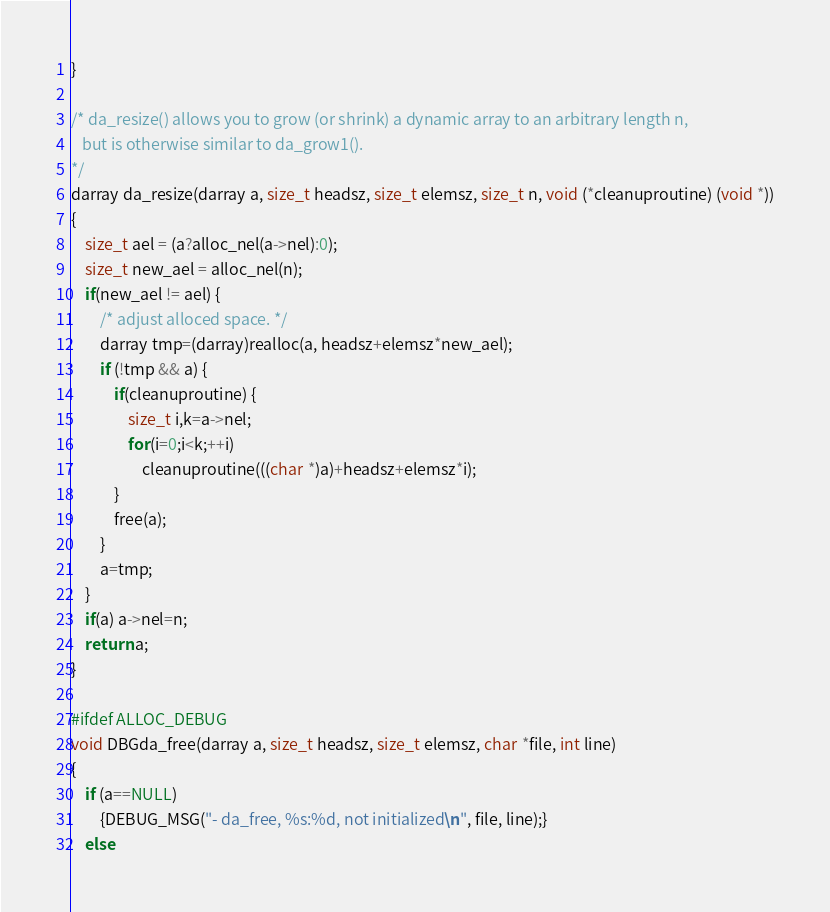Convert code to text. <code><loc_0><loc_0><loc_500><loc_500><_C_>}

/* da_resize() allows you to grow (or shrink) a dynamic array to an arbitrary length n,
   but is otherwise similar to da_grow1().
*/
darray da_resize(darray a, size_t headsz, size_t elemsz, size_t n, void (*cleanuproutine) (void *))
{
	size_t ael = (a?alloc_nel(a->nel):0);
	size_t new_ael = alloc_nel(n);
	if(new_ael != ael) {
		/* adjust alloced space. */
		darray tmp=(darray)realloc(a, headsz+elemsz*new_ael);
		if (!tmp && a) {
			if(cleanuproutine) {
				size_t i,k=a->nel;
				for(i=0;i<k;++i)
					cleanuproutine(((char *)a)+headsz+elemsz*i);
			}
			free(a);
		}
		a=tmp;
	}
	if(a) a->nel=n;
	return a;
}

#ifdef ALLOC_DEBUG
void DBGda_free(darray a, size_t headsz, size_t elemsz, char *file, int line)
{
	if (a==NULL)
		{DEBUG_MSG("- da_free, %s:%d, not initialized\n", file, line);}
	else</code> 